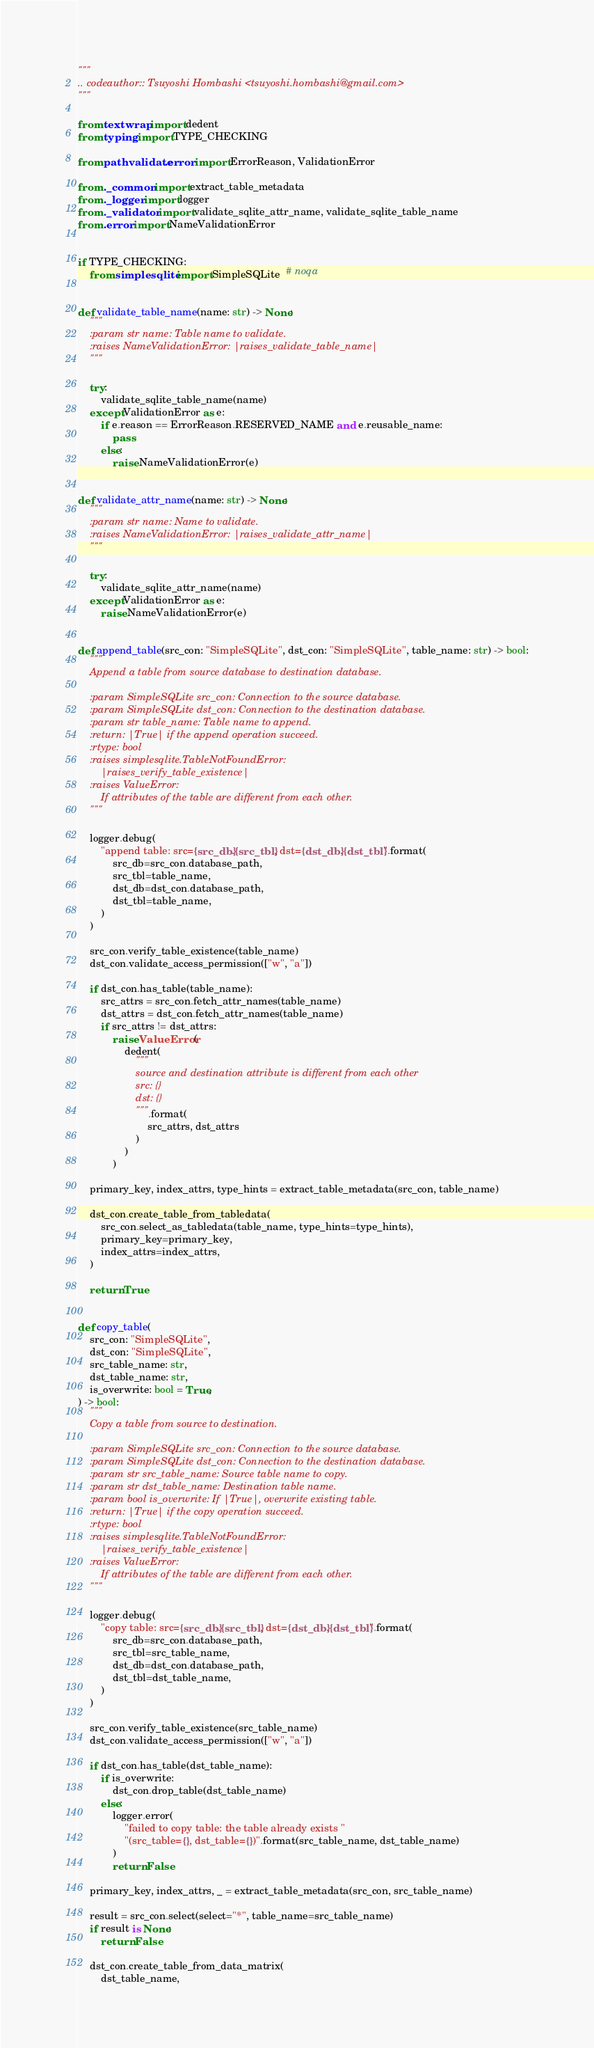Convert code to text. <code><loc_0><loc_0><loc_500><loc_500><_Python_>"""
.. codeauthor:: Tsuyoshi Hombashi <tsuyoshi.hombashi@gmail.com>
"""

from textwrap import dedent
from typing import TYPE_CHECKING

from pathvalidate.error import ErrorReason, ValidationError

from ._common import extract_table_metadata
from ._logger import logger
from ._validator import validate_sqlite_attr_name, validate_sqlite_table_name
from .error import NameValidationError


if TYPE_CHECKING:
    from simplesqlite import SimpleSQLite  # noqa


def validate_table_name(name: str) -> None:
    """
    :param str name: Table name to validate.
    :raises NameValidationError: |raises_validate_table_name|
    """

    try:
        validate_sqlite_table_name(name)
    except ValidationError as e:
        if e.reason == ErrorReason.RESERVED_NAME and e.reusable_name:
            pass
        else:
            raise NameValidationError(e)


def validate_attr_name(name: str) -> None:
    """
    :param str name: Name to validate.
    :raises NameValidationError: |raises_validate_attr_name|
    """

    try:
        validate_sqlite_attr_name(name)
    except ValidationError as e:
        raise NameValidationError(e)


def append_table(src_con: "SimpleSQLite", dst_con: "SimpleSQLite", table_name: str) -> bool:
    """
    Append a table from source database to destination database.

    :param SimpleSQLite src_con: Connection to the source database.
    :param SimpleSQLite dst_con: Connection to the destination database.
    :param str table_name: Table name to append.
    :return: |True| if the append operation succeed.
    :rtype: bool
    :raises simplesqlite.TableNotFoundError:
        |raises_verify_table_existence|
    :raises ValueError:
        If attributes of the table are different from each other.
    """

    logger.debug(
        "append table: src={src_db}.{src_tbl}, dst={dst_db}.{dst_tbl}".format(
            src_db=src_con.database_path,
            src_tbl=table_name,
            dst_db=dst_con.database_path,
            dst_tbl=table_name,
        )
    )

    src_con.verify_table_existence(table_name)
    dst_con.validate_access_permission(["w", "a"])

    if dst_con.has_table(table_name):
        src_attrs = src_con.fetch_attr_names(table_name)
        dst_attrs = dst_con.fetch_attr_names(table_name)
        if src_attrs != dst_attrs:
            raise ValueError(
                dedent(
                    """
                    source and destination attribute is different from each other
                    src: {}
                    dst: {}
                    """.format(
                        src_attrs, dst_attrs
                    )
                )
            )

    primary_key, index_attrs, type_hints = extract_table_metadata(src_con, table_name)

    dst_con.create_table_from_tabledata(
        src_con.select_as_tabledata(table_name, type_hints=type_hints),
        primary_key=primary_key,
        index_attrs=index_attrs,
    )

    return True


def copy_table(
    src_con: "SimpleSQLite",
    dst_con: "SimpleSQLite",
    src_table_name: str,
    dst_table_name: str,
    is_overwrite: bool = True,
) -> bool:
    """
    Copy a table from source to destination.

    :param SimpleSQLite src_con: Connection to the source database.
    :param SimpleSQLite dst_con: Connection to the destination database.
    :param str src_table_name: Source table name to copy.
    :param str dst_table_name: Destination table name.
    :param bool is_overwrite: If |True|, overwrite existing table.
    :return: |True| if the copy operation succeed.
    :rtype: bool
    :raises simplesqlite.TableNotFoundError:
        |raises_verify_table_existence|
    :raises ValueError:
        If attributes of the table are different from each other.
    """

    logger.debug(
        "copy table: src={src_db}.{src_tbl}, dst={dst_db}.{dst_tbl}".format(
            src_db=src_con.database_path,
            src_tbl=src_table_name,
            dst_db=dst_con.database_path,
            dst_tbl=dst_table_name,
        )
    )

    src_con.verify_table_existence(src_table_name)
    dst_con.validate_access_permission(["w", "a"])

    if dst_con.has_table(dst_table_name):
        if is_overwrite:
            dst_con.drop_table(dst_table_name)
        else:
            logger.error(
                "failed to copy table: the table already exists "
                "(src_table={}, dst_table={})".format(src_table_name, dst_table_name)
            )
            return False

    primary_key, index_attrs, _ = extract_table_metadata(src_con, src_table_name)

    result = src_con.select(select="*", table_name=src_table_name)
    if result is None:
        return False

    dst_con.create_table_from_data_matrix(
        dst_table_name,</code> 